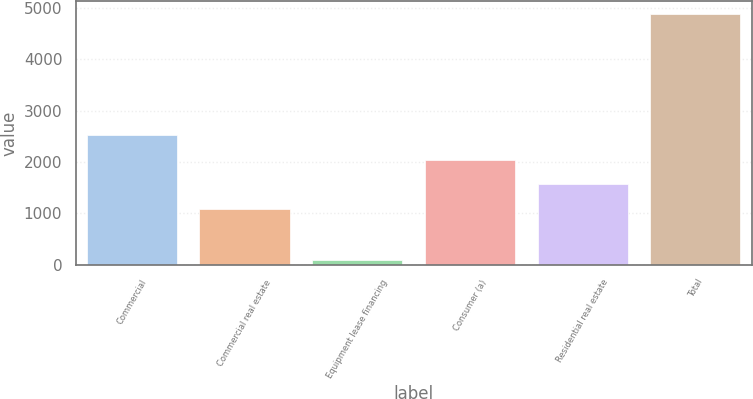<chart> <loc_0><loc_0><loc_500><loc_500><bar_chart><fcel>Commercial<fcel>Commercial real estate<fcel>Equipment lease financing<fcel>Consumer (a)<fcel>Residential real estate<fcel>Total<nl><fcel>2523.9<fcel>1086<fcel>94<fcel>2044.6<fcel>1565.3<fcel>4887<nl></chart> 